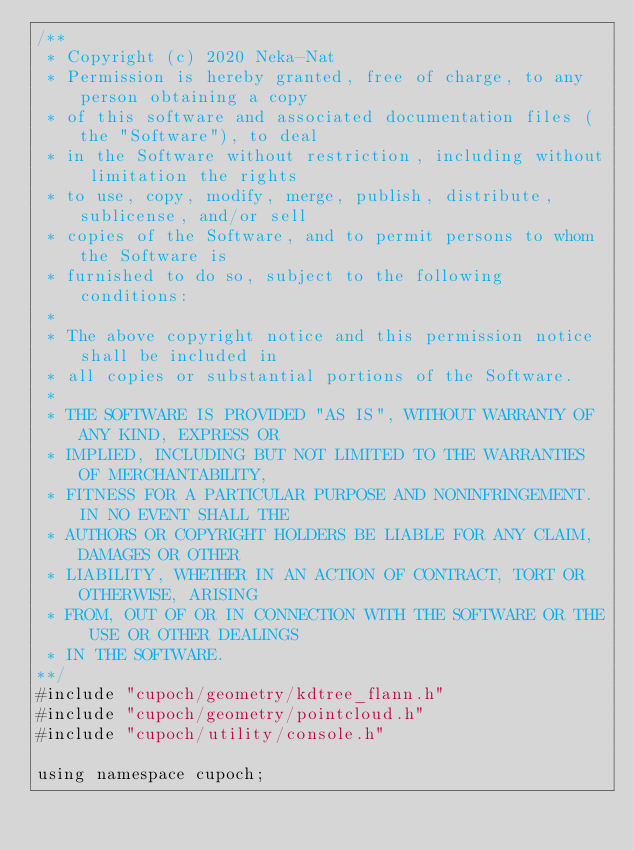<code> <loc_0><loc_0><loc_500><loc_500><_Cuda_>/**
 * Copyright (c) 2020 Neka-Nat
 * Permission is hereby granted, free of charge, to any person obtaining a copy
 * of this software and associated documentation files (the "Software"), to deal
 * in the Software without restriction, including without limitation the rights
 * to use, copy, modify, merge, publish, distribute, sublicense, and/or sell
 * copies of the Software, and to permit persons to whom the Software is
 * furnished to do so, subject to the following conditions:
 * 
 * The above copyright notice and this permission notice shall be included in
 * all copies or substantial portions of the Software.
 * 
 * THE SOFTWARE IS PROVIDED "AS IS", WITHOUT WARRANTY OF ANY KIND, EXPRESS OR
 * IMPLIED, INCLUDING BUT NOT LIMITED TO THE WARRANTIES OF MERCHANTABILITY,
 * FITNESS FOR A PARTICULAR PURPOSE AND NONINFRINGEMENT. IN NO EVENT SHALL THE
 * AUTHORS OR COPYRIGHT HOLDERS BE LIABLE FOR ANY CLAIM, DAMAGES OR OTHER
 * LIABILITY, WHETHER IN AN ACTION OF CONTRACT, TORT OR OTHERWISE, ARISING
 * FROM, OUT OF OR IN CONNECTION WITH THE SOFTWARE OR THE USE OR OTHER DEALINGS
 * IN THE SOFTWARE.
**/
#include "cupoch/geometry/kdtree_flann.h"
#include "cupoch/geometry/pointcloud.h"
#include "cupoch/utility/console.h"

using namespace cupoch;</code> 